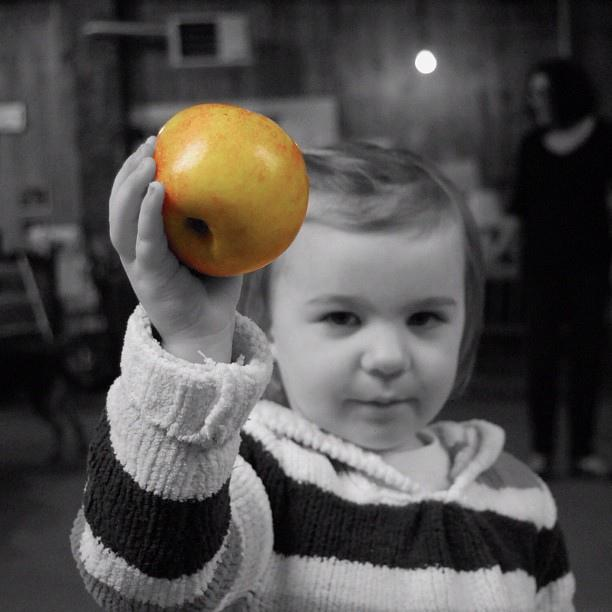What happens to the image?

Choices:
A) blurred
B) too bright
C) too dark
D) photoshopped photoshopped 